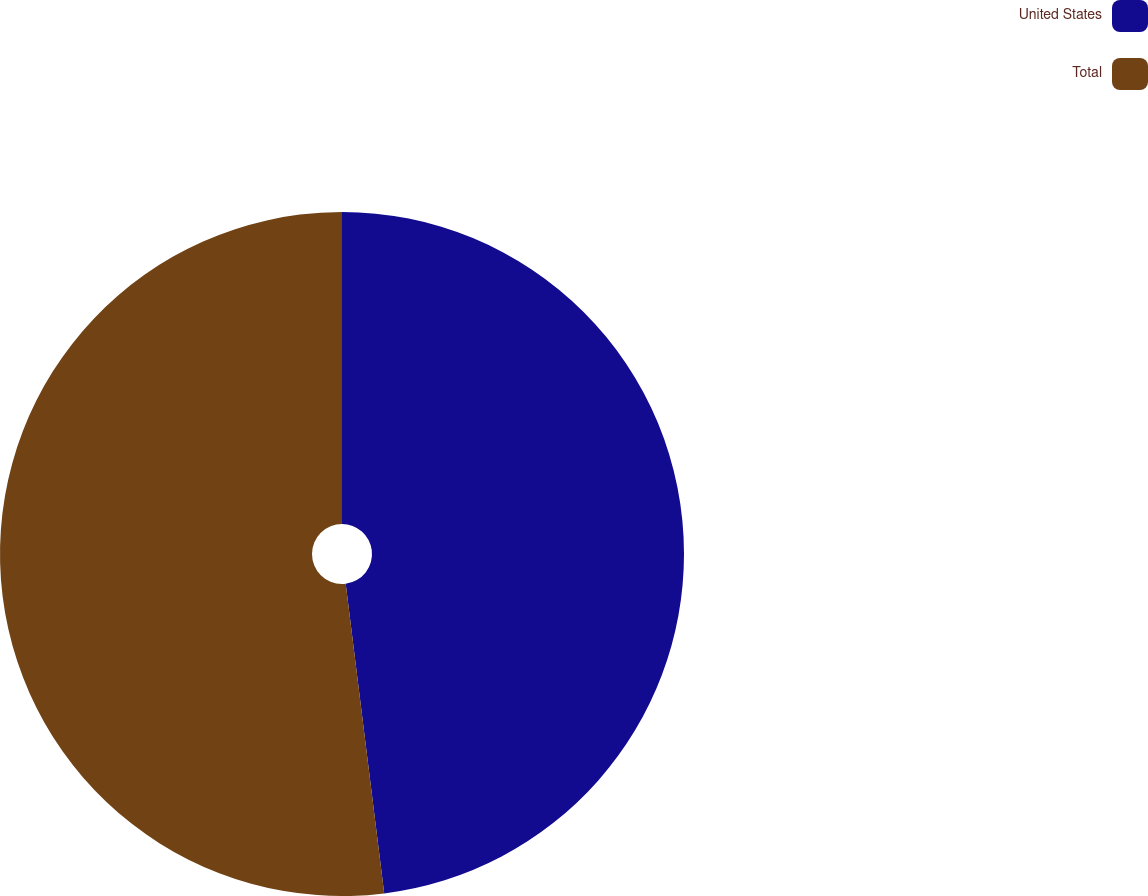Convert chart to OTSL. <chart><loc_0><loc_0><loc_500><loc_500><pie_chart><fcel>United States<fcel>Total<nl><fcel>48.03%<fcel>51.97%<nl></chart> 